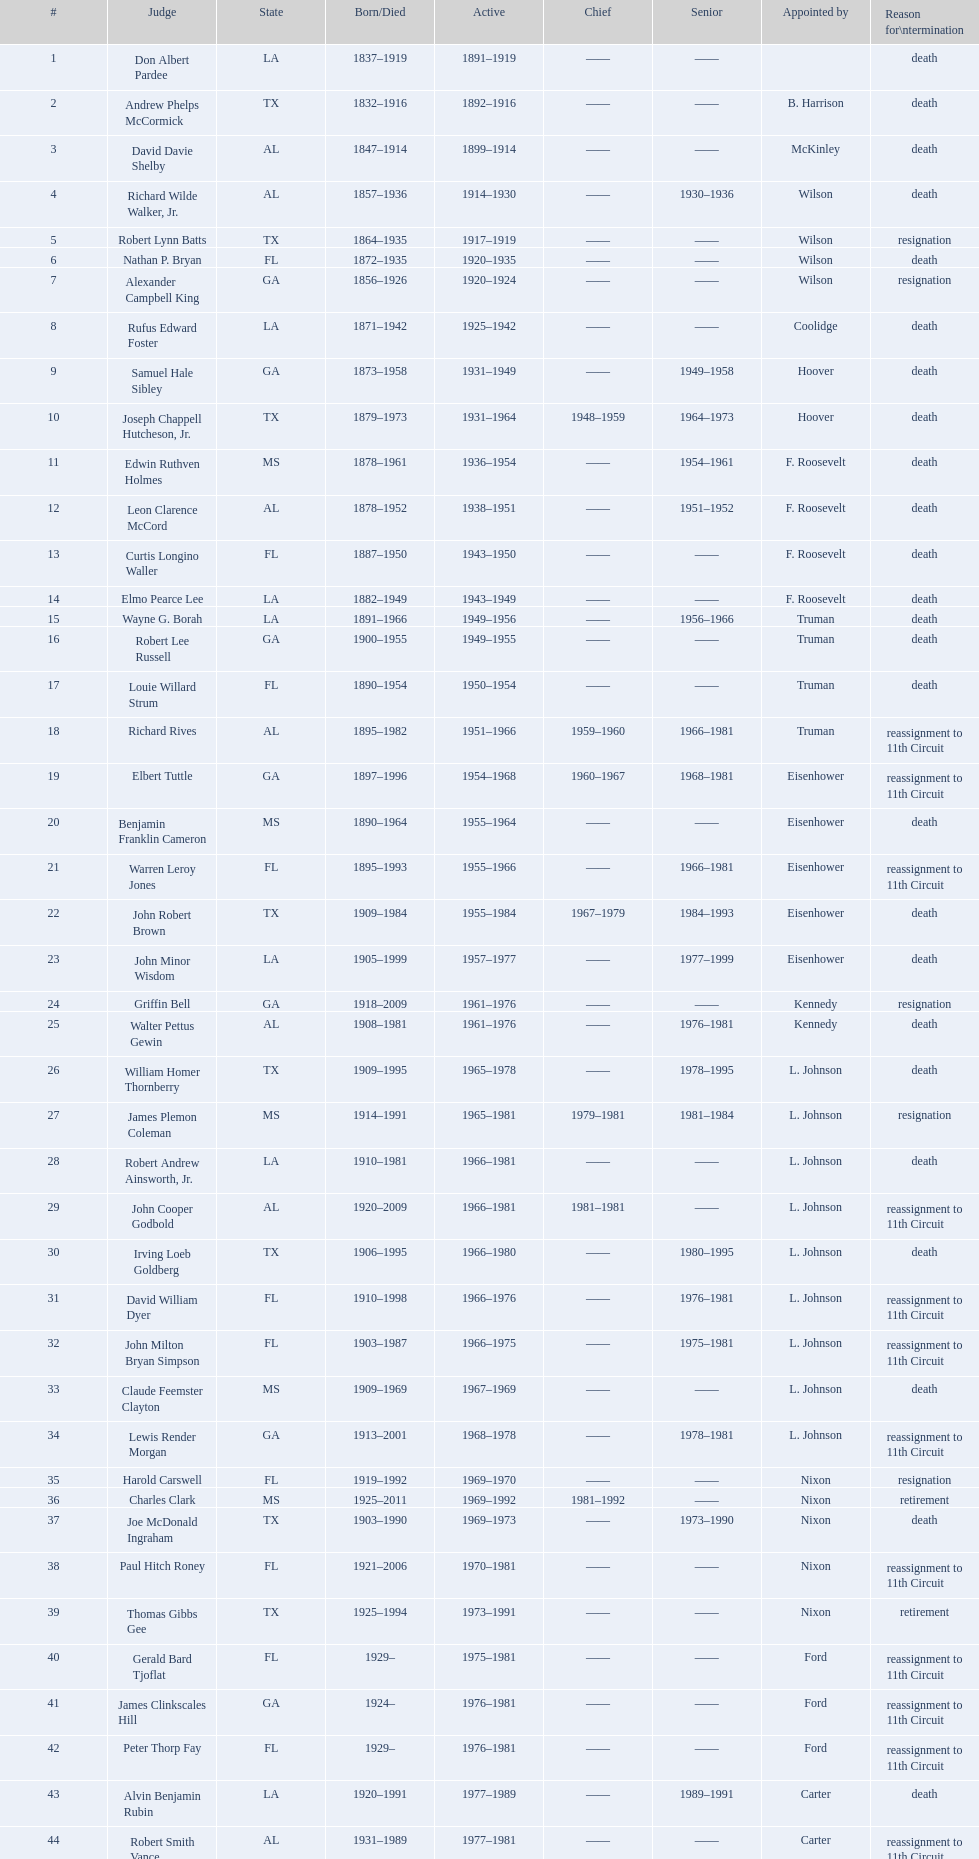Who was the only magistrate selected by mckinley? David Davie Shelby. 